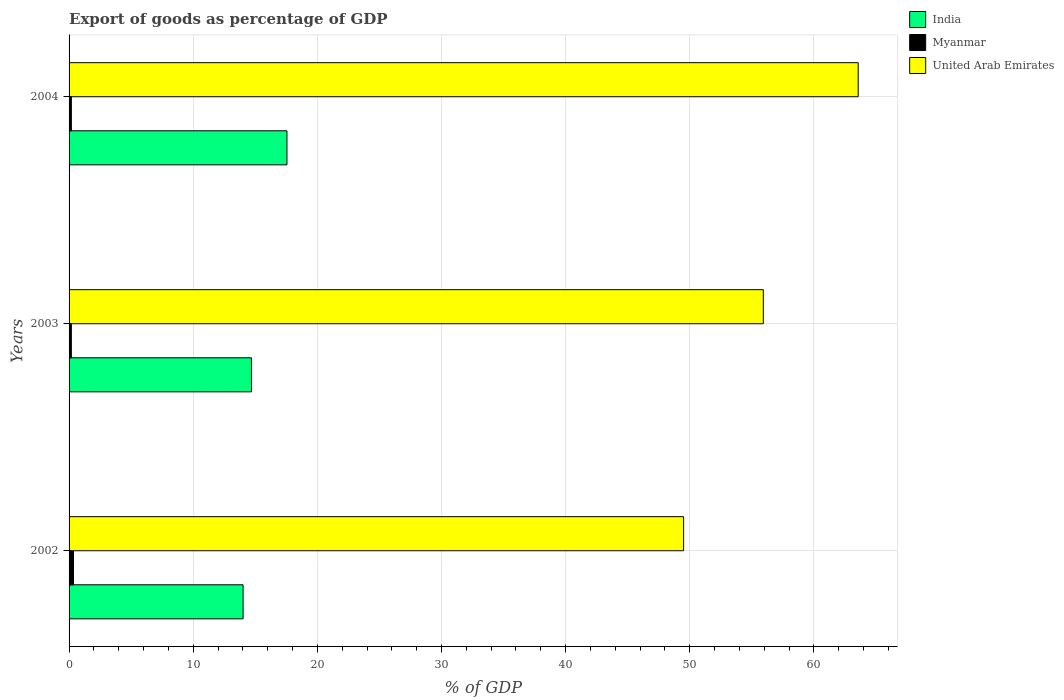How many different coloured bars are there?
Ensure brevity in your answer.  3. How many groups of bars are there?
Make the answer very short. 3. Are the number of bars per tick equal to the number of legend labels?
Ensure brevity in your answer.  Yes. How many bars are there on the 2nd tick from the top?
Keep it short and to the point. 3. What is the label of the 2nd group of bars from the top?
Provide a short and direct response. 2003. In how many cases, is the number of bars for a given year not equal to the number of legend labels?
Your answer should be very brief. 0. What is the export of goods as percentage of GDP in Myanmar in 2002?
Your answer should be compact. 0.35. Across all years, what is the maximum export of goods as percentage of GDP in India?
Ensure brevity in your answer.  17.55. Across all years, what is the minimum export of goods as percentage of GDP in United Arab Emirates?
Provide a succinct answer. 49.5. In which year was the export of goods as percentage of GDP in India minimum?
Your answer should be compact. 2002. What is the total export of goods as percentage of GDP in United Arab Emirates in the graph?
Your answer should be very brief. 168.99. What is the difference between the export of goods as percentage of GDP in United Arab Emirates in 2002 and that in 2004?
Your answer should be very brief. -14.06. What is the difference between the export of goods as percentage of GDP in United Arab Emirates in 2004 and the export of goods as percentage of GDP in India in 2002?
Keep it short and to the point. 49.55. What is the average export of goods as percentage of GDP in United Arab Emirates per year?
Offer a very short reply. 56.33. In the year 2004, what is the difference between the export of goods as percentage of GDP in United Arab Emirates and export of goods as percentage of GDP in Myanmar?
Provide a succinct answer. 63.38. In how many years, is the export of goods as percentage of GDP in India greater than 56 %?
Your response must be concise. 0. What is the ratio of the export of goods as percentage of GDP in Myanmar in 2002 to that in 2003?
Give a very brief answer. 1.94. What is the difference between the highest and the second highest export of goods as percentage of GDP in India?
Keep it short and to the point. 2.86. What is the difference between the highest and the lowest export of goods as percentage of GDP in India?
Provide a succinct answer. 3.53. What does the 2nd bar from the top in 2004 represents?
Keep it short and to the point. Myanmar. Is it the case that in every year, the sum of the export of goods as percentage of GDP in India and export of goods as percentage of GDP in United Arab Emirates is greater than the export of goods as percentage of GDP in Myanmar?
Provide a short and direct response. Yes. How many bars are there?
Offer a terse response. 9. Are all the bars in the graph horizontal?
Ensure brevity in your answer.  Yes. Are the values on the major ticks of X-axis written in scientific E-notation?
Offer a terse response. No. Does the graph contain any zero values?
Your response must be concise. No. Where does the legend appear in the graph?
Offer a very short reply. Top right. How many legend labels are there?
Your answer should be very brief. 3. What is the title of the graph?
Offer a terse response. Export of goods as percentage of GDP. Does "Vanuatu" appear as one of the legend labels in the graph?
Your answer should be compact. No. What is the label or title of the X-axis?
Make the answer very short. % of GDP. What is the label or title of the Y-axis?
Offer a very short reply. Years. What is the % of GDP of India in 2002?
Offer a terse response. 14.02. What is the % of GDP in Myanmar in 2002?
Make the answer very short. 0.35. What is the % of GDP in United Arab Emirates in 2002?
Provide a succinct answer. 49.5. What is the % of GDP of India in 2003?
Your answer should be compact. 14.69. What is the % of GDP in Myanmar in 2003?
Keep it short and to the point. 0.18. What is the % of GDP in United Arab Emirates in 2003?
Your answer should be very brief. 55.92. What is the % of GDP in India in 2004?
Provide a succinct answer. 17.55. What is the % of GDP of Myanmar in 2004?
Give a very brief answer. 0.18. What is the % of GDP of United Arab Emirates in 2004?
Your answer should be compact. 63.57. Across all years, what is the maximum % of GDP in India?
Offer a terse response. 17.55. Across all years, what is the maximum % of GDP of Myanmar?
Offer a very short reply. 0.35. Across all years, what is the maximum % of GDP of United Arab Emirates?
Provide a succinct answer. 63.57. Across all years, what is the minimum % of GDP of India?
Your answer should be compact. 14.02. Across all years, what is the minimum % of GDP of Myanmar?
Your answer should be compact. 0.18. Across all years, what is the minimum % of GDP of United Arab Emirates?
Provide a short and direct response. 49.5. What is the total % of GDP in India in the graph?
Make the answer very short. 46.26. What is the total % of GDP of Myanmar in the graph?
Your response must be concise. 0.72. What is the total % of GDP of United Arab Emirates in the graph?
Offer a terse response. 168.99. What is the difference between the % of GDP of India in 2002 and that in 2003?
Provide a short and direct response. -0.67. What is the difference between the % of GDP of Myanmar in 2002 and that in 2003?
Your answer should be compact. 0.17. What is the difference between the % of GDP of United Arab Emirates in 2002 and that in 2003?
Your answer should be very brief. -6.42. What is the difference between the % of GDP of India in 2002 and that in 2004?
Your answer should be very brief. -3.53. What is the difference between the % of GDP in Myanmar in 2002 and that in 2004?
Provide a succinct answer. 0.17. What is the difference between the % of GDP of United Arab Emirates in 2002 and that in 2004?
Provide a succinct answer. -14.06. What is the difference between the % of GDP of India in 2003 and that in 2004?
Keep it short and to the point. -2.86. What is the difference between the % of GDP in Myanmar in 2003 and that in 2004?
Provide a short and direct response. -0. What is the difference between the % of GDP in United Arab Emirates in 2003 and that in 2004?
Offer a very short reply. -7.64. What is the difference between the % of GDP in India in 2002 and the % of GDP in Myanmar in 2003?
Ensure brevity in your answer.  13.84. What is the difference between the % of GDP in India in 2002 and the % of GDP in United Arab Emirates in 2003?
Provide a succinct answer. -41.9. What is the difference between the % of GDP in Myanmar in 2002 and the % of GDP in United Arab Emirates in 2003?
Provide a short and direct response. -55.57. What is the difference between the % of GDP of India in 2002 and the % of GDP of Myanmar in 2004?
Provide a succinct answer. 13.83. What is the difference between the % of GDP of India in 2002 and the % of GDP of United Arab Emirates in 2004?
Give a very brief answer. -49.55. What is the difference between the % of GDP of Myanmar in 2002 and the % of GDP of United Arab Emirates in 2004?
Offer a very short reply. -63.21. What is the difference between the % of GDP of India in 2003 and the % of GDP of Myanmar in 2004?
Offer a terse response. 14.51. What is the difference between the % of GDP of India in 2003 and the % of GDP of United Arab Emirates in 2004?
Ensure brevity in your answer.  -48.88. What is the difference between the % of GDP in Myanmar in 2003 and the % of GDP in United Arab Emirates in 2004?
Offer a very short reply. -63.38. What is the average % of GDP of India per year?
Ensure brevity in your answer.  15.42. What is the average % of GDP of Myanmar per year?
Ensure brevity in your answer.  0.24. What is the average % of GDP in United Arab Emirates per year?
Your answer should be compact. 56.33. In the year 2002, what is the difference between the % of GDP of India and % of GDP of Myanmar?
Provide a succinct answer. 13.66. In the year 2002, what is the difference between the % of GDP in India and % of GDP in United Arab Emirates?
Ensure brevity in your answer.  -35.48. In the year 2002, what is the difference between the % of GDP of Myanmar and % of GDP of United Arab Emirates?
Give a very brief answer. -49.15. In the year 2003, what is the difference between the % of GDP of India and % of GDP of Myanmar?
Keep it short and to the point. 14.51. In the year 2003, what is the difference between the % of GDP in India and % of GDP in United Arab Emirates?
Make the answer very short. -41.23. In the year 2003, what is the difference between the % of GDP in Myanmar and % of GDP in United Arab Emirates?
Provide a succinct answer. -55.74. In the year 2004, what is the difference between the % of GDP in India and % of GDP in Myanmar?
Offer a very short reply. 17.37. In the year 2004, what is the difference between the % of GDP in India and % of GDP in United Arab Emirates?
Ensure brevity in your answer.  -46.02. In the year 2004, what is the difference between the % of GDP in Myanmar and % of GDP in United Arab Emirates?
Ensure brevity in your answer.  -63.38. What is the ratio of the % of GDP in India in 2002 to that in 2003?
Your answer should be compact. 0.95. What is the ratio of the % of GDP in Myanmar in 2002 to that in 2003?
Provide a short and direct response. 1.94. What is the ratio of the % of GDP in United Arab Emirates in 2002 to that in 2003?
Ensure brevity in your answer.  0.89. What is the ratio of the % of GDP of India in 2002 to that in 2004?
Offer a very short reply. 0.8. What is the ratio of the % of GDP of Myanmar in 2002 to that in 2004?
Keep it short and to the point. 1.93. What is the ratio of the % of GDP in United Arab Emirates in 2002 to that in 2004?
Your answer should be very brief. 0.78. What is the ratio of the % of GDP of India in 2003 to that in 2004?
Make the answer very short. 0.84. What is the ratio of the % of GDP of United Arab Emirates in 2003 to that in 2004?
Your answer should be compact. 0.88. What is the difference between the highest and the second highest % of GDP of India?
Provide a succinct answer. 2.86. What is the difference between the highest and the second highest % of GDP in Myanmar?
Offer a very short reply. 0.17. What is the difference between the highest and the second highest % of GDP of United Arab Emirates?
Give a very brief answer. 7.64. What is the difference between the highest and the lowest % of GDP of India?
Your response must be concise. 3.53. What is the difference between the highest and the lowest % of GDP in Myanmar?
Offer a very short reply. 0.17. What is the difference between the highest and the lowest % of GDP of United Arab Emirates?
Provide a succinct answer. 14.06. 